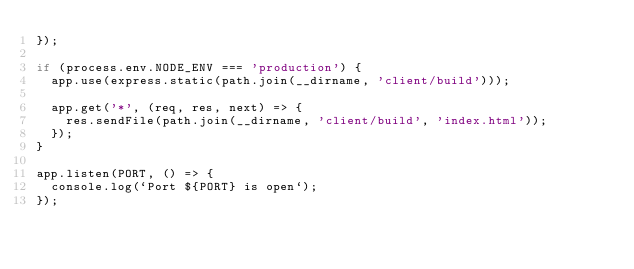<code> <loc_0><loc_0><loc_500><loc_500><_JavaScript_>});

if (process.env.NODE_ENV === 'production') {
  app.use(express.static(path.join(__dirname, 'client/build')));

  app.get('*', (req, res, next) => {
    res.sendFile(path.join(__dirname, 'client/build', 'index.html'));
  });
}

app.listen(PORT, () => {
  console.log(`Port ${PORT} is open`);
});
</code> 